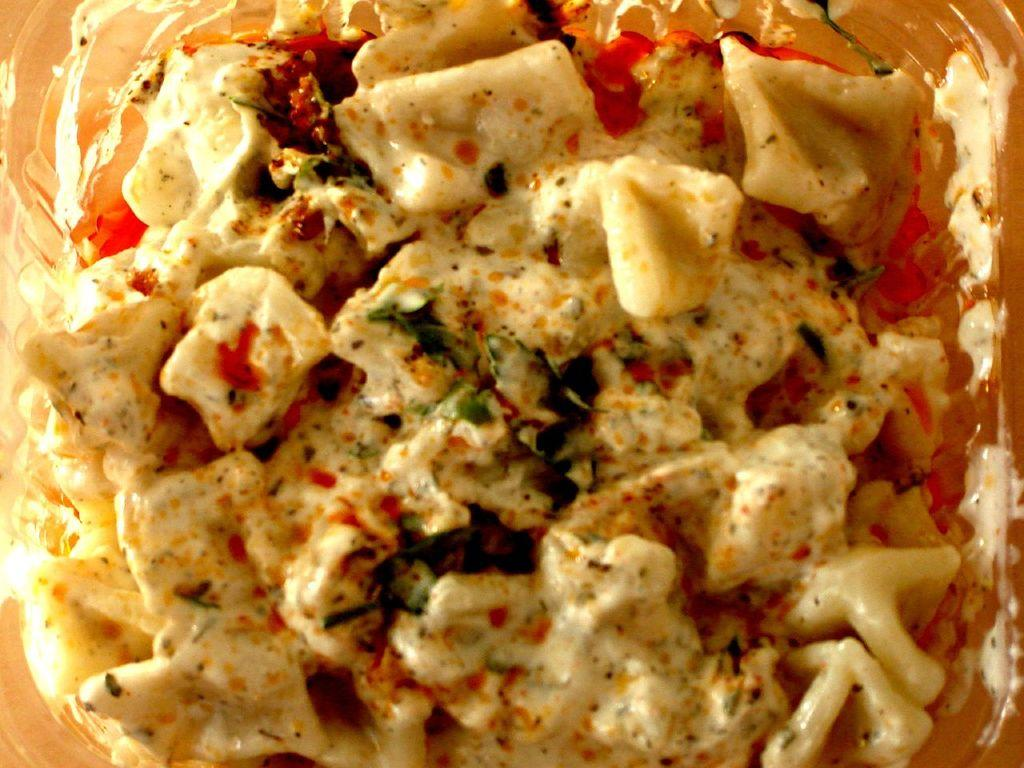What is in the bowl that is visible in the image? There is food in a bowl in the image. What accompanies the food in the bowl? There are sauces present in the image. How does the food play with the sauces in the image? The food does not play with the sauces in the image; it is simply accompanied by them. 